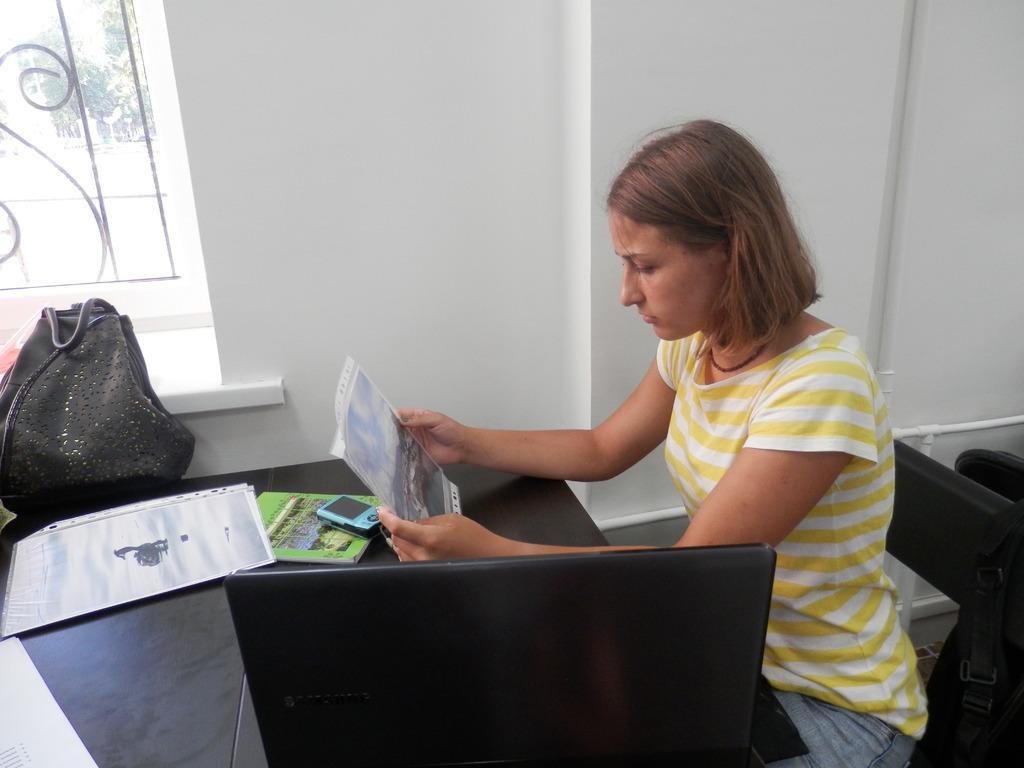Can you describe this image briefly? In the image we can see the lady on the right side and looking at the paper. And in front of her there is a table, on table they were few objects like book,phone and bag which is in black color. And they were few chairs and back there is a wall. 